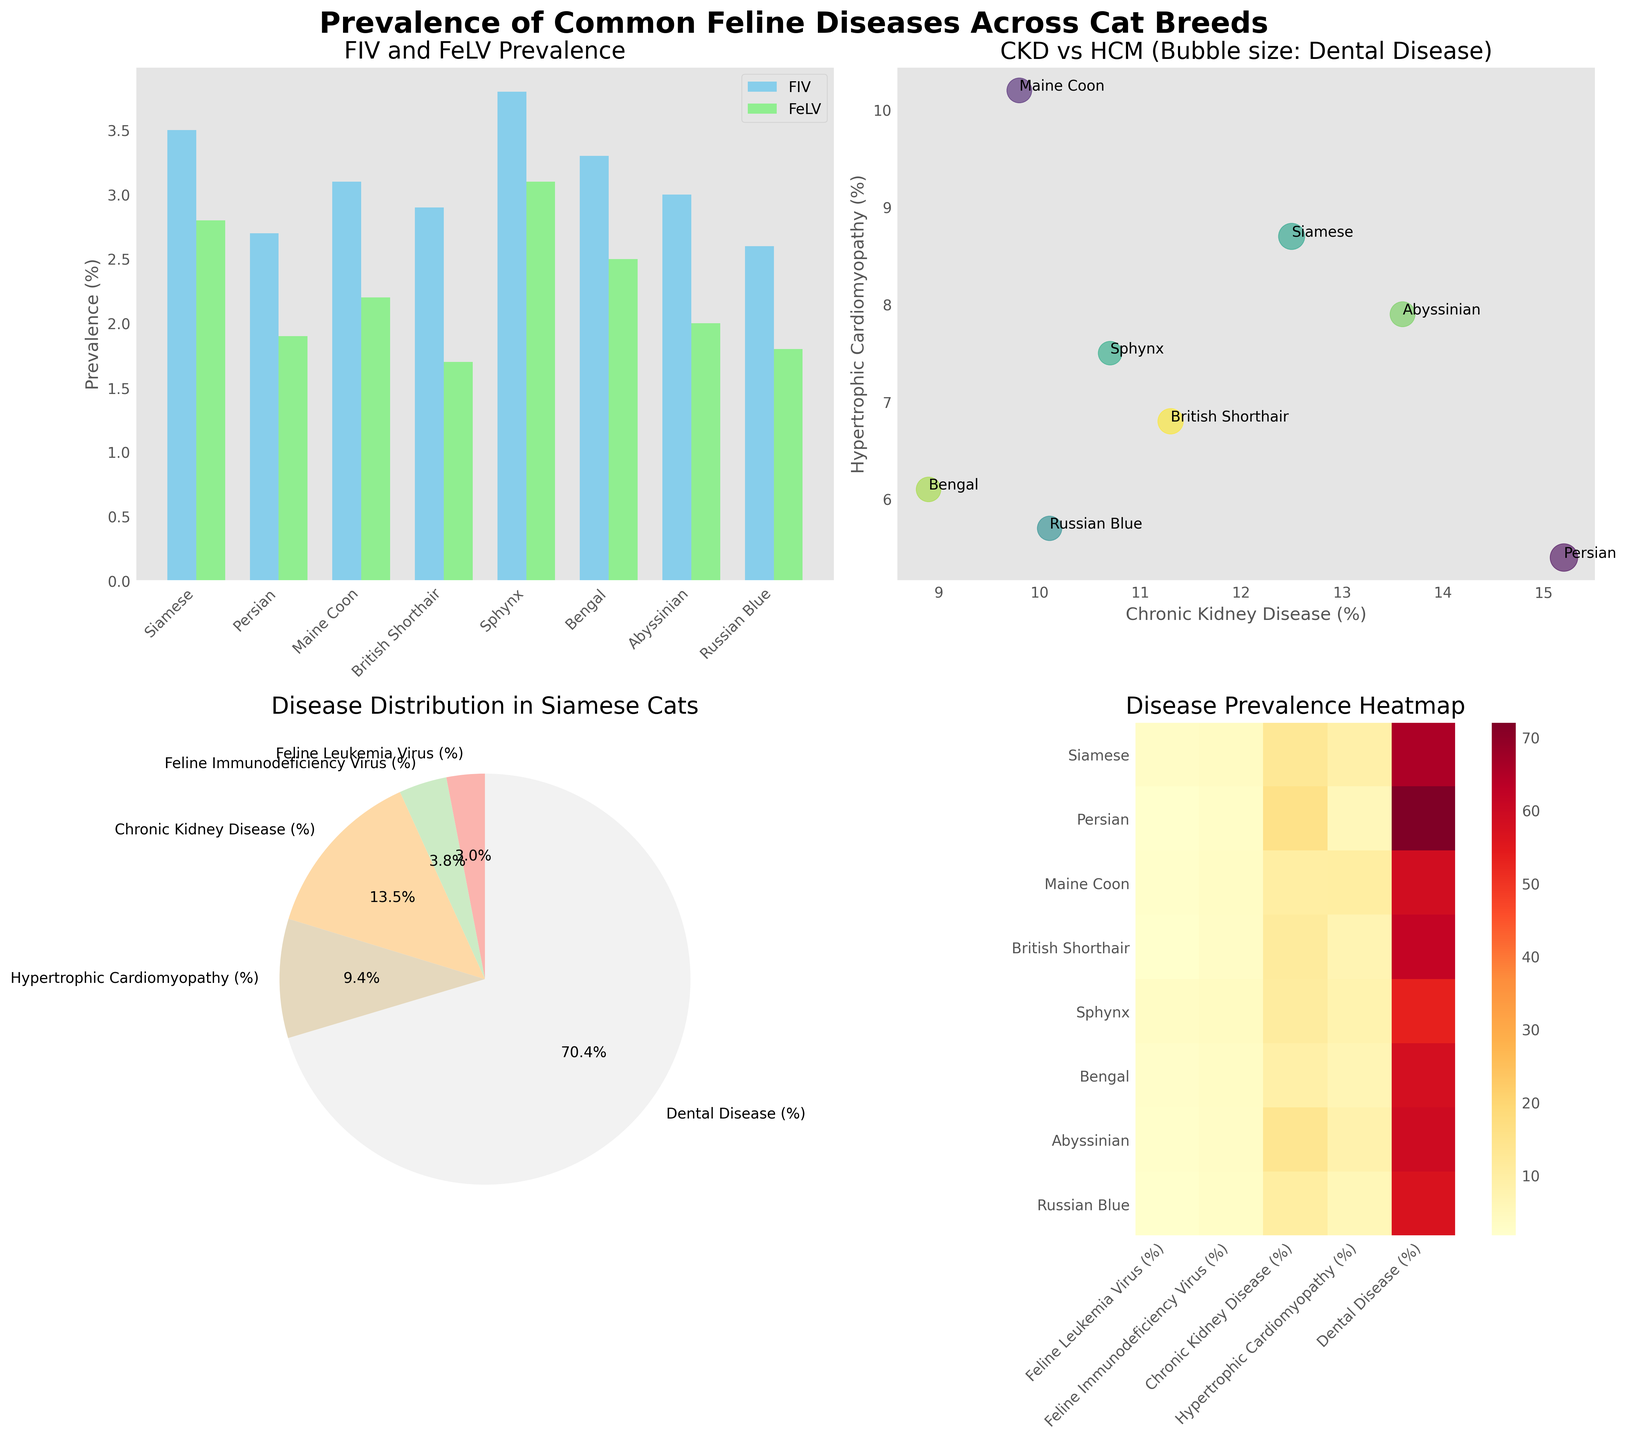What are the breeds with the highest and lowest prevalence of Feline Leukemia Virus (FeLV)? To find the breeds with the highest and lowest prevalence of FeLV, look at the heights of the light green bars in the bar plot on the top left. The breed with the highest bar is Sphynx with 3.1%, and the breed with the lowest bar is British Shorthair with 1.7%.
Answer: Sphynx, British Shorthair What is the percentage prevalence of Dental Disease in Siamese cats according to the pie chart? The pie chart on the bottom left shows the distribution of diseases in Siamese cats. Look at the segment labeled "Dental Disease (%)" to find the percentage. It shows 65.3%.
Answer: 65.3% How does the prevalence of Chronic Kidney Disease (CKD) compare between Persian and Maine Coon breeds? Refer to the heatmap in the bottom right subplot and look at the Chronic Kidney Disease row. The Persian breed has a prevalence of 15.2% for CKD, while Maine Coon has 9.8%. Hence, Persian has a higher prevalence of CKD compared to Maine Coon.
Answer: Persian > Maine Coon What diseases have nearly equal prevalence rates in Siamese cats? From the pie chart for Siamese cats, compare the segments. The prevalence rates of Feline Leukemia Virus (2.8%) and Feline Immunodeficiency Virus (3.5%) are nearly equal.
Answer: Feline Leukemia Virus, Feline Immunodeficiency Virus Which breed has the largest bubble in the scatter plot, and what does it represent? The scatter plot for CKD vs HCM uses bubble size to represent Dental Disease prevalence. The largest bubble corresponds to the Persian breed, indicating it has the highest prevalence of Dental Disease at 72.1%.
Answer: Persian Among the breeds shown, which has the highest prevalence of Hypertrophic Cardiomyopathy (HCM)? Check the scatter plot on the top right and find the point farthest along the y-axis. Maine Coon has the highest prevalence of HCM at 10.2%.
Answer: Maine Coon On the heatmap, which disease is indicated to be most prevalent among all breeds combined? In the heatmap at the bottom right, the disease with the highest overall values or more intense colors represents the most prevalence. Dental Disease has consistently higher values across all breeds.
Answer: Dental Disease What relationship, if any, can be observed between Chronic Kidney Disease (CKD) and Hypertrophic Cardiomyopathy (HCM) in the scatter plot? By focusing on the scatter plot's x and y axes labeled CKD and HCM respectively, there doesn't seem to be a clear linear relationship as the points are scattered without a consistent trend.
Answer: No clear relationship What are the labels and corresponding percentages for each disease segment in the pie chart for Siamese cats? The pie chart labels diseases and their percentages for Siamese cats. The labels and percentages are: Feline Leukemia Virus (2.8%), Feline Immunodeficiency Virus (3.5%), Chronic Kidney Disease (12.5%), Hypertrophic Cardiomyopathy (8.7%), and Dental Disease (65.3%).
Answer: FeLV: 2.8%, FIV: 3.5%, CKD: 12.5%, HCM: 8.7%, Dental Disease: 65.3% Which breed has the lowest prevalence of Feline Immunodeficiency Virus (FIV), and what is the value? In the bar chart comparing FeLV and FIV prevalence, the lowest FIV prevalence is indicated by the shortest sky blue bar. The British Shorthair has the lowest at 2.6%.
Answer: British Shorthair, 2.6% 